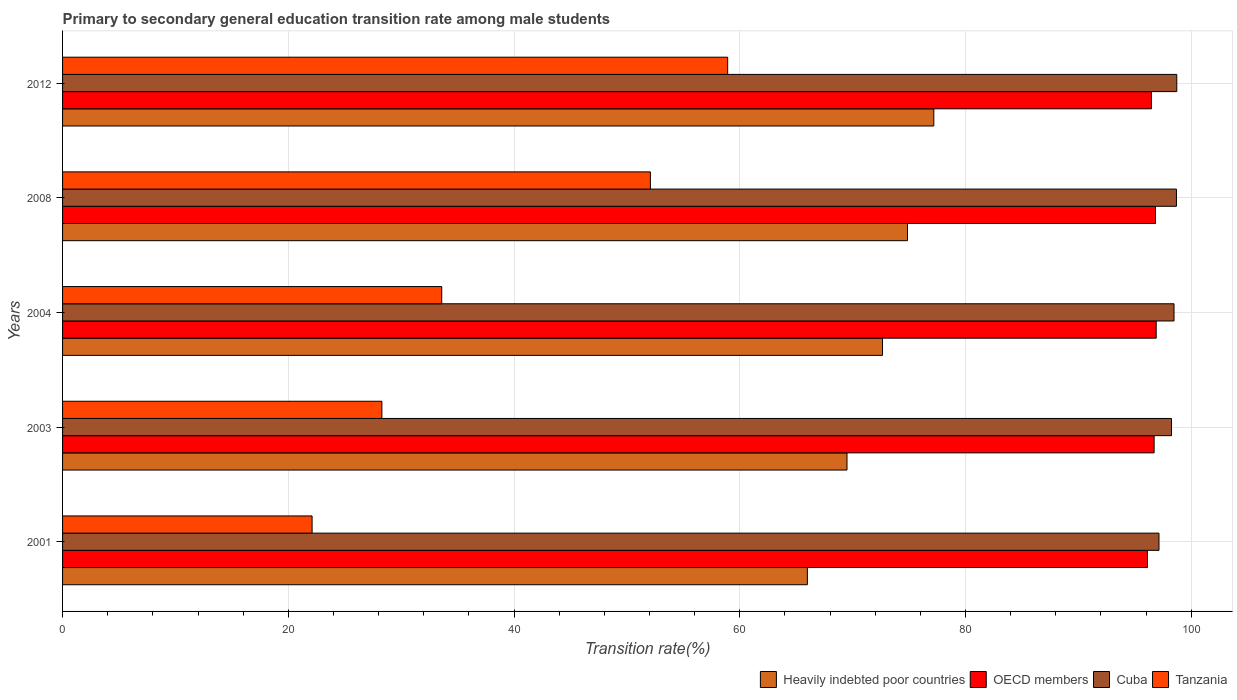How many different coloured bars are there?
Make the answer very short. 4. Are the number of bars on each tick of the Y-axis equal?
Provide a succinct answer. Yes. How many bars are there on the 4th tick from the top?
Ensure brevity in your answer.  4. How many bars are there on the 1st tick from the bottom?
Keep it short and to the point. 4. In how many cases, is the number of bars for a given year not equal to the number of legend labels?
Keep it short and to the point. 0. What is the transition rate in Heavily indebted poor countries in 2008?
Your response must be concise. 74.86. Across all years, what is the maximum transition rate in Tanzania?
Your response must be concise. 58.93. Across all years, what is the minimum transition rate in Cuba?
Ensure brevity in your answer.  97.14. What is the total transition rate in OECD members in the graph?
Keep it short and to the point. 483.02. What is the difference between the transition rate in Heavily indebted poor countries in 2001 and that in 2008?
Your answer should be very brief. -8.87. What is the difference between the transition rate in Tanzania in 2008 and the transition rate in OECD members in 2012?
Offer a very short reply. -44.39. What is the average transition rate in Tanzania per year?
Make the answer very short. 39. In the year 2012, what is the difference between the transition rate in Tanzania and transition rate in OECD members?
Keep it short and to the point. -37.54. What is the ratio of the transition rate in Heavily indebted poor countries in 2001 to that in 2012?
Offer a terse response. 0.85. Is the transition rate in OECD members in 2004 less than that in 2008?
Ensure brevity in your answer.  No. Is the difference between the transition rate in Tanzania in 2004 and 2008 greater than the difference between the transition rate in OECD members in 2004 and 2008?
Keep it short and to the point. No. What is the difference between the highest and the second highest transition rate in Cuba?
Your answer should be compact. 0.03. What is the difference between the highest and the lowest transition rate in OECD members?
Your answer should be compact. 0.77. Is it the case that in every year, the sum of the transition rate in Heavily indebted poor countries and transition rate in Cuba is greater than the sum of transition rate in Tanzania and transition rate in OECD members?
Provide a short and direct response. No. What does the 1st bar from the top in 2004 represents?
Your response must be concise. Tanzania. What does the 4th bar from the bottom in 2008 represents?
Ensure brevity in your answer.  Tanzania. Is it the case that in every year, the sum of the transition rate in Tanzania and transition rate in OECD members is greater than the transition rate in Cuba?
Offer a very short reply. Yes. How many bars are there?
Your answer should be very brief. 20. How many years are there in the graph?
Offer a very short reply. 5. Are the values on the major ticks of X-axis written in scientific E-notation?
Keep it short and to the point. No. Where does the legend appear in the graph?
Make the answer very short. Bottom right. How are the legend labels stacked?
Make the answer very short. Horizontal. What is the title of the graph?
Offer a very short reply. Primary to secondary general education transition rate among male students. Does "Singapore" appear as one of the legend labels in the graph?
Keep it short and to the point. No. What is the label or title of the X-axis?
Offer a terse response. Transition rate(%). What is the label or title of the Y-axis?
Make the answer very short. Years. What is the Transition rate(%) in Heavily indebted poor countries in 2001?
Keep it short and to the point. 65.99. What is the Transition rate(%) of OECD members in 2001?
Keep it short and to the point. 96.12. What is the Transition rate(%) of Cuba in 2001?
Offer a very short reply. 97.14. What is the Transition rate(%) in Tanzania in 2001?
Offer a very short reply. 22.11. What is the Transition rate(%) in Heavily indebted poor countries in 2003?
Keep it short and to the point. 69.5. What is the Transition rate(%) in OECD members in 2003?
Ensure brevity in your answer.  96.71. What is the Transition rate(%) of Cuba in 2003?
Offer a very short reply. 98.25. What is the Transition rate(%) of Tanzania in 2003?
Give a very brief answer. 28.29. What is the Transition rate(%) in Heavily indebted poor countries in 2004?
Provide a short and direct response. 72.65. What is the Transition rate(%) in OECD members in 2004?
Provide a succinct answer. 96.89. What is the Transition rate(%) in Cuba in 2004?
Offer a very short reply. 98.47. What is the Transition rate(%) of Tanzania in 2004?
Your answer should be very brief. 33.59. What is the Transition rate(%) of Heavily indebted poor countries in 2008?
Offer a very short reply. 74.86. What is the Transition rate(%) of OECD members in 2008?
Offer a terse response. 96.83. What is the Transition rate(%) of Cuba in 2008?
Offer a very short reply. 98.69. What is the Transition rate(%) of Tanzania in 2008?
Ensure brevity in your answer.  52.08. What is the Transition rate(%) of Heavily indebted poor countries in 2012?
Your answer should be very brief. 77.19. What is the Transition rate(%) of OECD members in 2012?
Give a very brief answer. 96.47. What is the Transition rate(%) of Cuba in 2012?
Ensure brevity in your answer.  98.72. What is the Transition rate(%) of Tanzania in 2012?
Offer a very short reply. 58.93. Across all years, what is the maximum Transition rate(%) of Heavily indebted poor countries?
Your response must be concise. 77.19. Across all years, what is the maximum Transition rate(%) of OECD members?
Offer a very short reply. 96.89. Across all years, what is the maximum Transition rate(%) of Cuba?
Offer a very short reply. 98.72. Across all years, what is the maximum Transition rate(%) of Tanzania?
Offer a very short reply. 58.93. Across all years, what is the minimum Transition rate(%) of Heavily indebted poor countries?
Your response must be concise. 65.99. Across all years, what is the minimum Transition rate(%) of OECD members?
Give a very brief answer. 96.12. Across all years, what is the minimum Transition rate(%) of Cuba?
Your answer should be compact. 97.14. Across all years, what is the minimum Transition rate(%) of Tanzania?
Make the answer very short. 22.11. What is the total Transition rate(%) of Heavily indebted poor countries in the graph?
Offer a very short reply. 360.18. What is the total Transition rate(%) of OECD members in the graph?
Provide a short and direct response. 483.02. What is the total Transition rate(%) in Cuba in the graph?
Ensure brevity in your answer.  491.26. What is the total Transition rate(%) of Tanzania in the graph?
Make the answer very short. 195. What is the difference between the Transition rate(%) in Heavily indebted poor countries in 2001 and that in 2003?
Offer a terse response. -3.51. What is the difference between the Transition rate(%) in OECD members in 2001 and that in 2003?
Your response must be concise. -0.59. What is the difference between the Transition rate(%) in Cuba in 2001 and that in 2003?
Keep it short and to the point. -1.11. What is the difference between the Transition rate(%) of Tanzania in 2001 and that in 2003?
Your answer should be compact. -6.18. What is the difference between the Transition rate(%) of Heavily indebted poor countries in 2001 and that in 2004?
Your answer should be compact. -6.66. What is the difference between the Transition rate(%) of OECD members in 2001 and that in 2004?
Your answer should be compact. -0.77. What is the difference between the Transition rate(%) in Cuba in 2001 and that in 2004?
Provide a short and direct response. -1.33. What is the difference between the Transition rate(%) in Tanzania in 2001 and that in 2004?
Offer a terse response. -11.49. What is the difference between the Transition rate(%) in Heavily indebted poor countries in 2001 and that in 2008?
Provide a succinct answer. -8.87. What is the difference between the Transition rate(%) of OECD members in 2001 and that in 2008?
Your answer should be compact. -0.71. What is the difference between the Transition rate(%) of Cuba in 2001 and that in 2008?
Your answer should be very brief. -1.55. What is the difference between the Transition rate(%) in Tanzania in 2001 and that in 2008?
Keep it short and to the point. -29.97. What is the difference between the Transition rate(%) of Heavily indebted poor countries in 2001 and that in 2012?
Make the answer very short. -11.2. What is the difference between the Transition rate(%) in OECD members in 2001 and that in 2012?
Ensure brevity in your answer.  -0.35. What is the difference between the Transition rate(%) of Cuba in 2001 and that in 2012?
Make the answer very short. -1.58. What is the difference between the Transition rate(%) of Tanzania in 2001 and that in 2012?
Provide a short and direct response. -36.82. What is the difference between the Transition rate(%) in Heavily indebted poor countries in 2003 and that in 2004?
Ensure brevity in your answer.  -3.15. What is the difference between the Transition rate(%) of OECD members in 2003 and that in 2004?
Offer a very short reply. -0.18. What is the difference between the Transition rate(%) of Cuba in 2003 and that in 2004?
Offer a terse response. -0.23. What is the difference between the Transition rate(%) in Tanzania in 2003 and that in 2004?
Provide a short and direct response. -5.3. What is the difference between the Transition rate(%) in Heavily indebted poor countries in 2003 and that in 2008?
Ensure brevity in your answer.  -5.36. What is the difference between the Transition rate(%) of OECD members in 2003 and that in 2008?
Give a very brief answer. -0.12. What is the difference between the Transition rate(%) in Cuba in 2003 and that in 2008?
Give a very brief answer. -0.44. What is the difference between the Transition rate(%) in Tanzania in 2003 and that in 2008?
Give a very brief answer. -23.79. What is the difference between the Transition rate(%) of Heavily indebted poor countries in 2003 and that in 2012?
Make the answer very short. -7.69. What is the difference between the Transition rate(%) in OECD members in 2003 and that in 2012?
Provide a short and direct response. 0.24. What is the difference between the Transition rate(%) in Cuba in 2003 and that in 2012?
Provide a succinct answer. -0.47. What is the difference between the Transition rate(%) in Tanzania in 2003 and that in 2012?
Your answer should be very brief. -30.64. What is the difference between the Transition rate(%) in Heavily indebted poor countries in 2004 and that in 2008?
Your response must be concise. -2.21. What is the difference between the Transition rate(%) in OECD members in 2004 and that in 2008?
Your answer should be very brief. 0.06. What is the difference between the Transition rate(%) in Cuba in 2004 and that in 2008?
Offer a very short reply. -0.21. What is the difference between the Transition rate(%) in Tanzania in 2004 and that in 2008?
Ensure brevity in your answer.  -18.49. What is the difference between the Transition rate(%) of Heavily indebted poor countries in 2004 and that in 2012?
Provide a short and direct response. -4.54. What is the difference between the Transition rate(%) in OECD members in 2004 and that in 2012?
Your response must be concise. 0.42. What is the difference between the Transition rate(%) in Cuba in 2004 and that in 2012?
Your response must be concise. -0.24. What is the difference between the Transition rate(%) of Tanzania in 2004 and that in 2012?
Your answer should be very brief. -25.33. What is the difference between the Transition rate(%) of Heavily indebted poor countries in 2008 and that in 2012?
Ensure brevity in your answer.  -2.33. What is the difference between the Transition rate(%) of OECD members in 2008 and that in 2012?
Make the answer very short. 0.36. What is the difference between the Transition rate(%) of Cuba in 2008 and that in 2012?
Your answer should be compact. -0.03. What is the difference between the Transition rate(%) in Tanzania in 2008 and that in 2012?
Offer a terse response. -6.85. What is the difference between the Transition rate(%) in Heavily indebted poor countries in 2001 and the Transition rate(%) in OECD members in 2003?
Offer a very short reply. -30.72. What is the difference between the Transition rate(%) of Heavily indebted poor countries in 2001 and the Transition rate(%) of Cuba in 2003?
Your answer should be compact. -32.26. What is the difference between the Transition rate(%) in Heavily indebted poor countries in 2001 and the Transition rate(%) in Tanzania in 2003?
Give a very brief answer. 37.7. What is the difference between the Transition rate(%) in OECD members in 2001 and the Transition rate(%) in Cuba in 2003?
Keep it short and to the point. -2.13. What is the difference between the Transition rate(%) in OECD members in 2001 and the Transition rate(%) in Tanzania in 2003?
Make the answer very short. 67.83. What is the difference between the Transition rate(%) of Cuba in 2001 and the Transition rate(%) of Tanzania in 2003?
Offer a very short reply. 68.85. What is the difference between the Transition rate(%) of Heavily indebted poor countries in 2001 and the Transition rate(%) of OECD members in 2004?
Your response must be concise. -30.9. What is the difference between the Transition rate(%) of Heavily indebted poor countries in 2001 and the Transition rate(%) of Cuba in 2004?
Provide a short and direct response. -32.48. What is the difference between the Transition rate(%) of Heavily indebted poor countries in 2001 and the Transition rate(%) of Tanzania in 2004?
Your answer should be very brief. 32.4. What is the difference between the Transition rate(%) of OECD members in 2001 and the Transition rate(%) of Cuba in 2004?
Keep it short and to the point. -2.36. What is the difference between the Transition rate(%) of OECD members in 2001 and the Transition rate(%) of Tanzania in 2004?
Provide a succinct answer. 62.52. What is the difference between the Transition rate(%) in Cuba in 2001 and the Transition rate(%) in Tanzania in 2004?
Provide a succinct answer. 63.55. What is the difference between the Transition rate(%) in Heavily indebted poor countries in 2001 and the Transition rate(%) in OECD members in 2008?
Make the answer very short. -30.84. What is the difference between the Transition rate(%) of Heavily indebted poor countries in 2001 and the Transition rate(%) of Cuba in 2008?
Give a very brief answer. -32.7. What is the difference between the Transition rate(%) of Heavily indebted poor countries in 2001 and the Transition rate(%) of Tanzania in 2008?
Provide a succinct answer. 13.91. What is the difference between the Transition rate(%) in OECD members in 2001 and the Transition rate(%) in Cuba in 2008?
Your answer should be compact. -2.57. What is the difference between the Transition rate(%) in OECD members in 2001 and the Transition rate(%) in Tanzania in 2008?
Offer a very short reply. 44.04. What is the difference between the Transition rate(%) of Cuba in 2001 and the Transition rate(%) of Tanzania in 2008?
Offer a terse response. 45.06. What is the difference between the Transition rate(%) in Heavily indebted poor countries in 2001 and the Transition rate(%) in OECD members in 2012?
Provide a succinct answer. -30.48. What is the difference between the Transition rate(%) in Heavily indebted poor countries in 2001 and the Transition rate(%) in Cuba in 2012?
Make the answer very short. -32.73. What is the difference between the Transition rate(%) in Heavily indebted poor countries in 2001 and the Transition rate(%) in Tanzania in 2012?
Your answer should be very brief. 7.06. What is the difference between the Transition rate(%) in OECD members in 2001 and the Transition rate(%) in Cuba in 2012?
Provide a short and direct response. -2.6. What is the difference between the Transition rate(%) in OECD members in 2001 and the Transition rate(%) in Tanzania in 2012?
Your answer should be compact. 37.19. What is the difference between the Transition rate(%) of Cuba in 2001 and the Transition rate(%) of Tanzania in 2012?
Give a very brief answer. 38.21. What is the difference between the Transition rate(%) of Heavily indebted poor countries in 2003 and the Transition rate(%) of OECD members in 2004?
Offer a terse response. -27.39. What is the difference between the Transition rate(%) of Heavily indebted poor countries in 2003 and the Transition rate(%) of Cuba in 2004?
Keep it short and to the point. -28.97. What is the difference between the Transition rate(%) of Heavily indebted poor countries in 2003 and the Transition rate(%) of Tanzania in 2004?
Provide a short and direct response. 35.91. What is the difference between the Transition rate(%) of OECD members in 2003 and the Transition rate(%) of Cuba in 2004?
Keep it short and to the point. -1.76. What is the difference between the Transition rate(%) in OECD members in 2003 and the Transition rate(%) in Tanzania in 2004?
Your answer should be compact. 63.12. What is the difference between the Transition rate(%) in Cuba in 2003 and the Transition rate(%) in Tanzania in 2004?
Make the answer very short. 64.65. What is the difference between the Transition rate(%) in Heavily indebted poor countries in 2003 and the Transition rate(%) in OECD members in 2008?
Your answer should be compact. -27.33. What is the difference between the Transition rate(%) of Heavily indebted poor countries in 2003 and the Transition rate(%) of Cuba in 2008?
Your answer should be very brief. -29.19. What is the difference between the Transition rate(%) of Heavily indebted poor countries in 2003 and the Transition rate(%) of Tanzania in 2008?
Offer a very short reply. 17.42. What is the difference between the Transition rate(%) of OECD members in 2003 and the Transition rate(%) of Cuba in 2008?
Offer a very short reply. -1.98. What is the difference between the Transition rate(%) of OECD members in 2003 and the Transition rate(%) of Tanzania in 2008?
Keep it short and to the point. 44.63. What is the difference between the Transition rate(%) of Cuba in 2003 and the Transition rate(%) of Tanzania in 2008?
Ensure brevity in your answer.  46.17. What is the difference between the Transition rate(%) in Heavily indebted poor countries in 2003 and the Transition rate(%) in OECD members in 2012?
Provide a short and direct response. -26.97. What is the difference between the Transition rate(%) of Heavily indebted poor countries in 2003 and the Transition rate(%) of Cuba in 2012?
Offer a terse response. -29.22. What is the difference between the Transition rate(%) in Heavily indebted poor countries in 2003 and the Transition rate(%) in Tanzania in 2012?
Provide a short and direct response. 10.57. What is the difference between the Transition rate(%) of OECD members in 2003 and the Transition rate(%) of Cuba in 2012?
Offer a very short reply. -2.01. What is the difference between the Transition rate(%) of OECD members in 2003 and the Transition rate(%) of Tanzania in 2012?
Offer a very short reply. 37.78. What is the difference between the Transition rate(%) in Cuba in 2003 and the Transition rate(%) in Tanzania in 2012?
Ensure brevity in your answer.  39.32. What is the difference between the Transition rate(%) in Heavily indebted poor countries in 2004 and the Transition rate(%) in OECD members in 2008?
Your response must be concise. -24.19. What is the difference between the Transition rate(%) in Heavily indebted poor countries in 2004 and the Transition rate(%) in Cuba in 2008?
Offer a terse response. -26.04. What is the difference between the Transition rate(%) of Heavily indebted poor countries in 2004 and the Transition rate(%) of Tanzania in 2008?
Your answer should be compact. 20.57. What is the difference between the Transition rate(%) of OECD members in 2004 and the Transition rate(%) of Cuba in 2008?
Offer a terse response. -1.8. What is the difference between the Transition rate(%) of OECD members in 2004 and the Transition rate(%) of Tanzania in 2008?
Provide a succinct answer. 44.81. What is the difference between the Transition rate(%) of Cuba in 2004 and the Transition rate(%) of Tanzania in 2008?
Your response must be concise. 46.39. What is the difference between the Transition rate(%) of Heavily indebted poor countries in 2004 and the Transition rate(%) of OECD members in 2012?
Give a very brief answer. -23.82. What is the difference between the Transition rate(%) in Heavily indebted poor countries in 2004 and the Transition rate(%) in Cuba in 2012?
Offer a very short reply. -26.07. What is the difference between the Transition rate(%) of Heavily indebted poor countries in 2004 and the Transition rate(%) of Tanzania in 2012?
Provide a short and direct response. 13.72. What is the difference between the Transition rate(%) of OECD members in 2004 and the Transition rate(%) of Cuba in 2012?
Make the answer very short. -1.82. What is the difference between the Transition rate(%) of OECD members in 2004 and the Transition rate(%) of Tanzania in 2012?
Provide a short and direct response. 37.97. What is the difference between the Transition rate(%) of Cuba in 2004 and the Transition rate(%) of Tanzania in 2012?
Make the answer very short. 39.55. What is the difference between the Transition rate(%) in Heavily indebted poor countries in 2008 and the Transition rate(%) in OECD members in 2012?
Make the answer very short. -21.61. What is the difference between the Transition rate(%) of Heavily indebted poor countries in 2008 and the Transition rate(%) of Cuba in 2012?
Provide a succinct answer. -23.86. What is the difference between the Transition rate(%) of Heavily indebted poor countries in 2008 and the Transition rate(%) of Tanzania in 2012?
Your answer should be very brief. 15.93. What is the difference between the Transition rate(%) of OECD members in 2008 and the Transition rate(%) of Cuba in 2012?
Provide a short and direct response. -1.89. What is the difference between the Transition rate(%) in OECD members in 2008 and the Transition rate(%) in Tanzania in 2012?
Ensure brevity in your answer.  37.9. What is the difference between the Transition rate(%) in Cuba in 2008 and the Transition rate(%) in Tanzania in 2012?
Make the answer very short. 39.76. What is the average Transition rate(%) of Heavily indebted poor countries per year?
Offer a terse response. 72.04. What is the average Transition rate(%) in OECD members per year?
Ensure brevity in your answer.  96.6. What is the average Transition rate(%) of Cuba per year?
Make the answer very short. 98.25. What is the average Transition rate(%) in Tanzania per year?
Offer a very short reply. 39. In the year 2001, what is the difference between the Transition rate(%) of Heavily indebted poor countries and Transition rate(%) of OECD members?
Offer a very short reply. -30.13. In the year 2001, what is the difference between the Transition rate(%) in Heavily indebted poor countries and Transition rate(%) in Cuba?
Keep it short and to the point. -31.15. In the year 2001, what is the difference between the Transition rate(%) of Heavily indebted poor countries and Transition rate(%) of Tanzania?
Your answer should be compact. 43.88. In the year 2001, what is the difference between the Transition rate(%) of OECD members and Transition rate(%) of Cuba?
Offer a terse response. -1.02. In the year 2001, what is the difference between the Transition rate(%) in OECD members and Transition rate(%) in Tanzania?
Keep it short and to the point. 74.01. In the year 2001, what is the difference between the Transition rate(%) of Cuba and Transition rate(%) of Tanzania?
Provide a short and direct response. 75.03. In the year 2003, what is the difference between the Transition rate(%) of Heavily indebted poor countries and Transition rate(%) of OECD members?
Your answer should be compact. -27.21. In the year 2003, what is the difference between the Transition rate(%) in Heavily indebted poor countries and Transition rate(%) in Cuba?
Your answer should be very brief. -28.75. In the year 2003, what is the difference between the Transition rate(%) of Heavily indebted poor countries and Transition rate(%) of Tanzania?
Your response must be concise. 41.21. In the year 2003, what is the difference between the Transition rate(%) of OECD members and Transition rate(%) of Cuba?
Make the answer very short. -1.54. In the year 2003, what is the difference between the Transition rate(%) in OECD members and Transition rate(%) in Tanzania?
Offer a terse response. 68.42. In the year 2003, what is the difference between the Transition rate(%) in Cuba and Transition rate(%) in Tanzania?
Make the answer very short. 69.96. In the year 2004, what is the difference between the Transition rate(%) in Heavily indebted poor countries and Transition rate(%) in OECD members?
Offer a very short reply. -24.25. In the year 2004, what is the difference between the Transition rate(%) in Heavily indebted poor countries and Transition rate(%) in Cuba?
Offer a very short reply. -25.83. In the year 2004, what is the difference between the Transition rate(%) in Heavily indebted poor countries and Transition rate(%) in Tanzania?
Keep it short and to the point. 39.05. In the year 2004, what is the difference between the Transition rate(%) in OECD members and Transition rate(%) in Cuba?
Your answer should be compact. -1.58. In the year 2004, what is the difference between the Transition rate(%) in OECD members and Transition rate(%) in Tanzania?
Ensure brevity in your answer.  63.3. In the year 2004, what is the difference between the Transition rate(%) of Cuba and Transition rate(%) of Tanzania?
Keep it short and to the point. 64.88. In the year 2008, what is the difference between the Transition rate(%) in Heavily indebted poor countries and Transition rate(%) in OECD members?
Make the answer very short. -21.97. In the year 2008, what is the difference between the Transition rate(%) of Heavily indebted poor countries and Transition rate(%) of Cuba?
Make the answer very short. -23.83. In the year 2008, what is the difference between the Transition rate(%) in Heavily indebted poor countries and Transition rate(%) in Tanzania?
Your answer should be compact. 22.78. In the year 2008, what is the difference between the Transition rate(%) in OECD members and Transition rate(%) in Cuba?
Provide a short and direct response. -1.86. In the year 2008, what is the difference between the Transition rate(%) in OECD members and Transition rate(%) in Tanzania?
Your response must be concise. 44.75. In the year 2008, what is the difference between the Transition rate(%) in Cuba and Transition rate(%) in Tanzania?
Your answer should be compact. 46.61. In the year 2012, what is the difference between the Transition rate(%) of Heavily indebted poor countries and Transition rate(%) of OECD members?
Make the answer very short. -19.28. In the year 2012, what is the difference between the Transition rate(%) of Heavily indebted poor countries and Transition rate(%) of Cuba?
Your answer should be compact. -21.53. In the year 2012, what is the difference between the Transition rate(%) in Heavily indebted poor countries and Transition rate(%) in Tanzania?
Make the answer very short. 18.26. In the year 2012, what is the difference between the Transition rate(%) in OECD members and Transition rate(%) in Cuba?
Ensure brevity in your answer.  -2.25. In the year 2012, what is the difference between the Transition rate(%) in OECD members and Transition rate(%) in Tanzania?
Offer a terse response. 37.54. In the year 2012, what is the difference between the Transition rate(%) of Cuba and Transition rate(%) of Tanzania?
Offer a very short reply. 39.79. What is the ratio of the Transition rate(%) of Heavily indebted poor countries in 2001 to that in 2003?
Your response must be concise. 0.95. What is the ratio of the Transition rate(%) of OECD members in 2001 to that in 2003?
Keep it short and to the point. 0.99. What is the ratio of the Transition rate(%) of Cuba in 2001 to that in 2003?
Offer a very short reply. 0.99. What is the ratio of the Transition rate(%) in Tanzania in 2001 to that in 2003?
Your response must be concise. 0.78. What is the ratio of the Transition rate(%) in Heavily indebted poor countries in 2001 to that in 2004?
Provide a succinct answer. 0.91. What is the ratio of the Transition rate(%) in Cuba in 2001 to that in 2004?
Give a very brief answer. 0.99. What is the ratio of the Transition rate(%) in Tanzania in 2001 to that in 2004?
Make the answer very short. 0.66. What is the ratio of the Transition rate(%) in Heavily indebted poor countries in 2001 to that in 2008?
Provide a succinct answer. 0.88. What is the ratio of the Transition rate(%) in OECD members in 2001 to that in 2008?
Offer a very short reply. 0.99. What is the ratio of the Transition rate(%) of Cuba in 2001 to that in 2008?
Give a very brief answer. 0.98. What is the ratio of the Transition rate(%) of Tanzania in 2001 to that in 2008?
Ensure brevity in your answer.  0.42. What is the ratio of the Transition rate(%) in Heavily indebted poor countries in 2001 to that in 2012?
Provide a short and direct response. 0.85. What is the ratio of the Transition rate(%) in OECD members in 2001 to that in 2012?
Keep it short and to the point. 1. What is the ratio of the Transition rate(%) in Tanzania in 2001 to that in 2012?
Keep it short and to the point. 0.38. What is the ratio of the Transition rate(%) of Heavily indebted poor countries in 2003 to that in 2004?
Your response must be concise. 0.96. What is the ratio of the Transition rate(%) of Cuba in 2003 to that in 2004?
Your response must be concise. 1. What is the ratio of the Transition rate(%) in Tanzania in 2003 to that in 2004?
Provide a short and direct response. 0.84. What is the ratio of the Transition rate(%) in Heavily indebted poor countries in 2003 to that in 2008?
Your answer should be very brief. 0.93. What is the ratio of the Transition rate(%) of Cuba in 2003 to that in 2008?
Provide a short and direct response. 1. What is the ratio of the Transition rate(%) of Tanzania in 2003 to that in 2008?
Provide a succinct answer. 0.54. What is the ratio of the Transition rate(%) of Heavily indebted poor countries in 2003 to that in 2012?
Your answer should be very brief. 0.9. What is the ratio of the Transition rate(%) in OECD members in 2003 to that in 2012?
Keep it short and to the point. 1. What is the ratio of the Transition rate(%) of Cuba in 2003 to that in 2012?
Ensure brevity in your answer.  1. What is the ratio of the Transition rate(%) of Tanzania in 2003 to that in 2012?
Your answer should be very brief. 0.48. What is the ratio of the Transition rate(%) of Heavily indebted poor countries in 2004 to that in 2008?
Give a very brief answer. 0.97. What is the ratio of the Transition rate(%) in Tanzania in 2004 to that in 2008?
Your answer should be compact. 0.65. What is the ratio of the Transition rate(%) of Heavily indebted poor countries in 2004 to that in 2012?
Offer a terse response. 0.94. What is the ratio of the Transition rate(%) in Cuba in 2004 to that in 2012?
Offer a terse response. 1. What is the ratio of the Transition rate(%) in Tanzania in 2004 to that in 2012?
Provide a short and direct response. 0.57. What is the ratio of the Transition rate(%) of Heavily indebted poor countries in 2008 to that in 2012?
Offer a terse response. 0.97. What is the ratio of the Transition rate(%) of Cuba in 2008 to that in 2012?
Offer a terse response. 1. What is the ratio of the Transition rate(%) in Tanzania in 2008 to that in 2012?
Provide a succinct answer. 0.88. What is the difference between the highest and the second highest Transition rate(%) in Heavily indebted poor countries?
Provide a short and direct response. 2.33. What is the difference between the highest and the second highest Transition rate(%) of OECD members?
Your answer should be compact. 0.06. What is the difference between the highest and the second highest Transition rate(%) of Cuba?
Your answer should be compact. 0.03. What is the difference between the highest and the second highest Transition rate(%) in Tanzania?
Offer a terse response. 6.85. What is the difference between the highest and the lowest Transition rate(%) of Heavily indebted poor countries?
Your response must be concise. 11.2. What is the difference between the highest and the lowest Transition rate(%) of OECD members?
Keep it short and to the point. 0.77. What is the difference between the highest and the lowest Transition rate(%) in Cuba?
Offer a terse response. 1.58. What is the difference between the highest and the lowest Transition rate(%) in Tanzania?
Offer a very short reply. 36.82. 